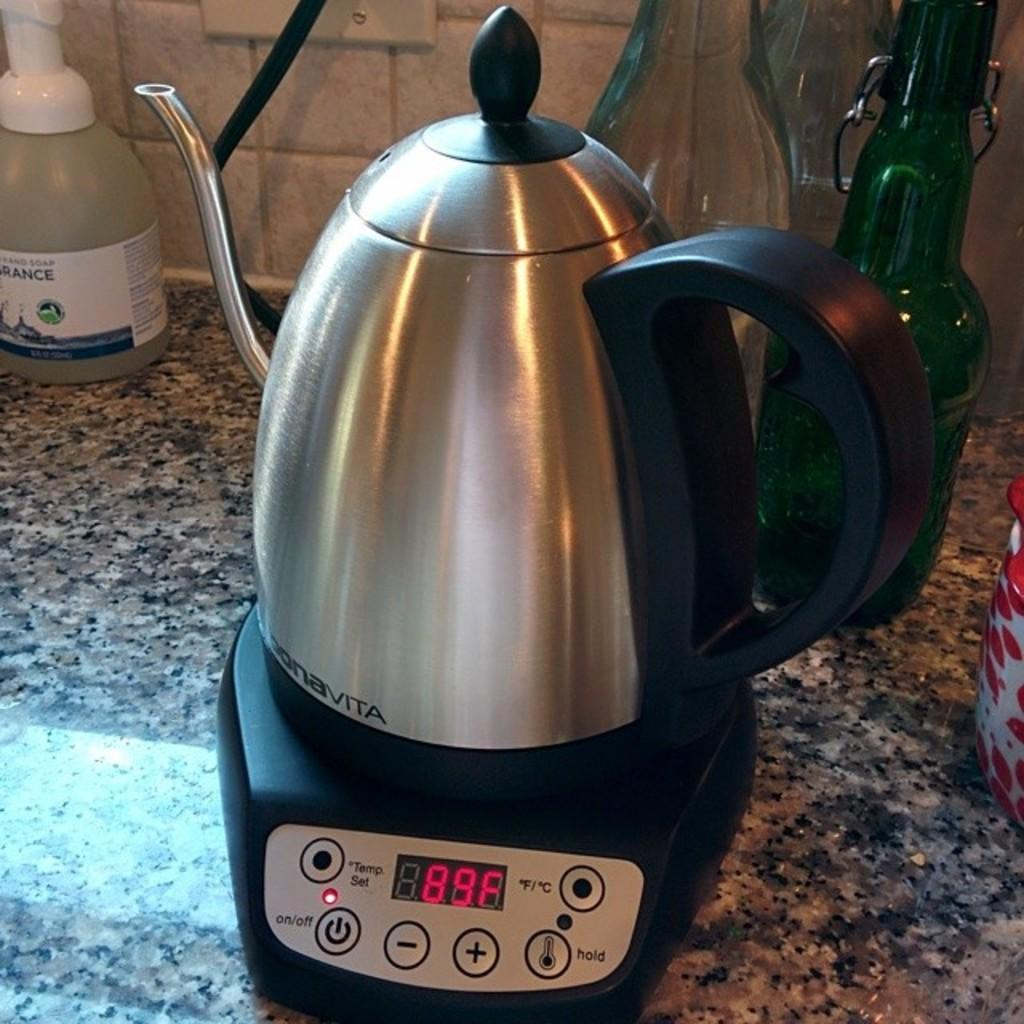What type of container is present in the image? There is a jug in the image. What other containers can be seen in the image? There are bottles in the image. What type of veil is draped over the bottles in the image? There is no veil present in the image; it only features a jug and bottles. 